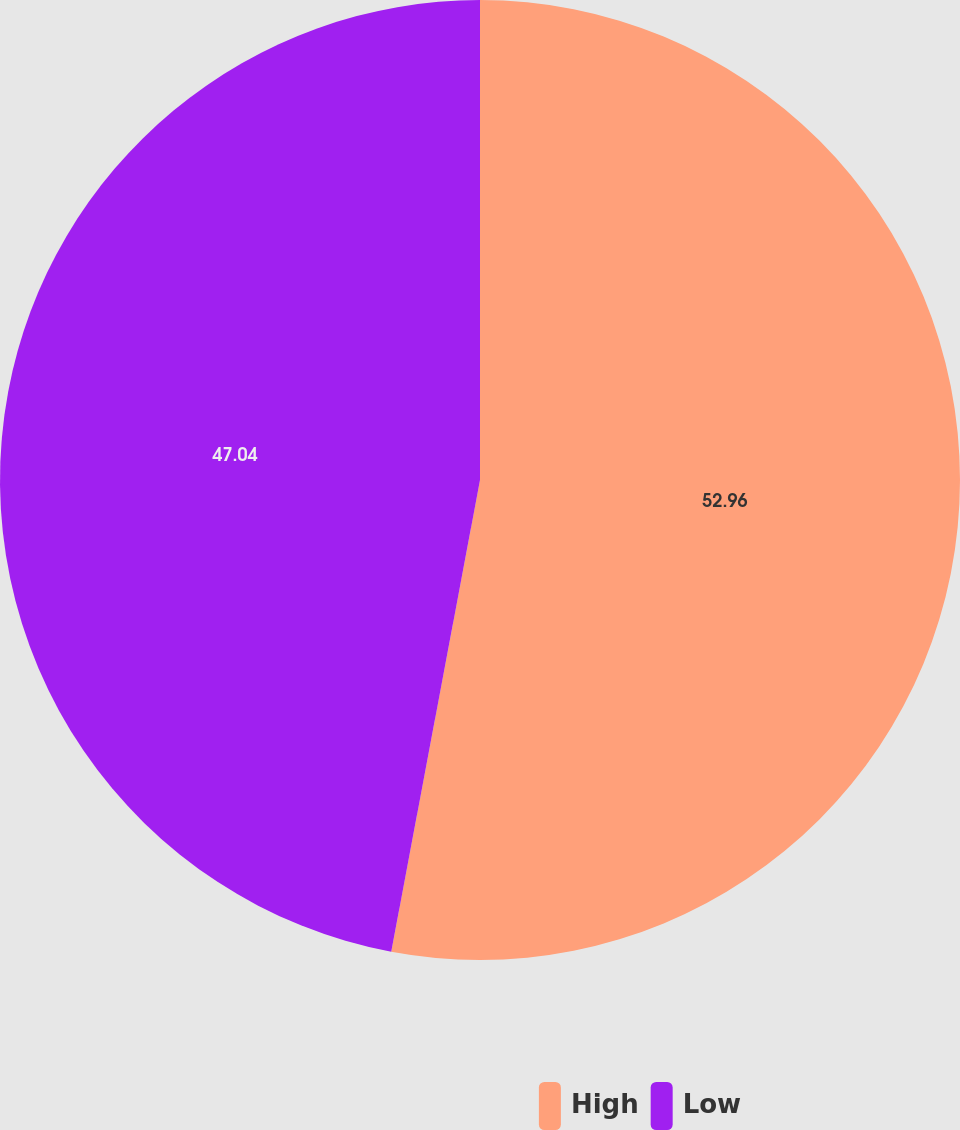<chart> <loc_0><loc_0><loc_500><loc_500><pie_chart><fcel>High<fcel>Low<nl><fcel>52.96%<fcel>47.04%<nl></chart> 